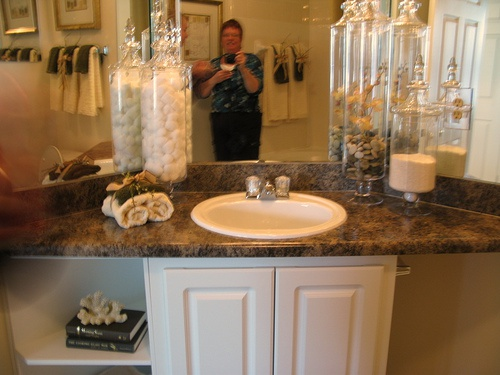Describe the objects in this image and their specific colors. I can see vase in olive, tan, darkgray, and beige tones, people in olive, black, maroon, and brown tones, vase in olive and tan tones, sink in olive, tan, and lightgray tones, and vase in olive, tan, and gray tones in this image. 